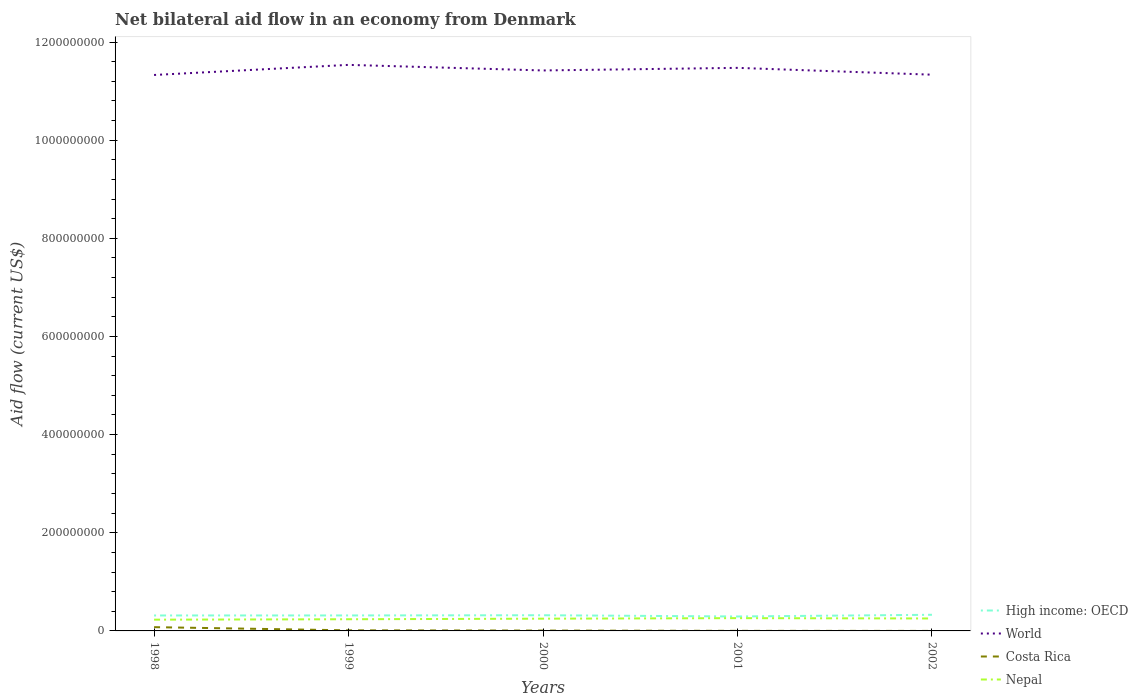Does the line corresponding to Nepal intersect with the line corresponding to High income: OECD?
Your answer should be compact. No. Is the number of lines equal to the number of legend labels?
Keep it short and to the point. Yes. Across all years, what is the maximum net bilateral aid flow in Nepal?
Keep it short and to the point. 2.29e+07. In which year was the net bilateral aid flow in Costa Rica maximum?
Give a very brief answer. 2002. What is the total net bilateral aid flow in Nepal in the graph?
Your response must be concise. -8.80e+05. What is the difference between the highest and the second highest net bilateral aid flow in High income: OECD?
Your answer should be very brief. 3.46e+06. What is the difference between the highest and the lowest net bilateral aid flow in High income: OECD?
Offer a very short reply. 4. Is the net bilateral aid flow in World strictly greater than the net bilateral aid flow in Costa Rica over the years?
Provide a succinct answer. No. How many years are there in the graph?
Ensure brevity in your answer.  5. Are the values on the major ticks of Y-axis written in scientific E-notation?
Make the answer very short. No. Does the graph contain any zero values?
Provide a short and direct response. No. Does the graph contain grids?
Keep it short and to the point. No. How are the legend labels stacked?
Your answer should be very brief. Vertical. What is the title of the graph?
Your response must be concise. Net bilateral aid flow in an economy from Denmark. What is the label or title of the X-axis?
Offer a terse response. Years. What is the Aid flow (current US$) in High income: OECD in 1998?
Make the answer very short. 3.15e+07. What is the Aid flow (current US$) in World in 1998?
Keep it short and to the point. 1.13e+09. What is the Aid flow (current US$) of Costa Rica in 1998?
Give a very brief answer. 7.68e+06. What is the Aid flow (current US$) of Nepal in 1998?
Your answer should be compact. 2.29e+07. What is the Aid flow (current US$) in High income: OECD in 1999?
Make the answer very short. 3.15e+07. What is the Aid flow (current US$) in World in 1999?
Provide a succinct answer. 1.15e+09. What is the Aid flow (current US$) of Costa Rica in 1999?
Your answer should be very brief. 1.19e+06. What is the Aid flow (current US$) in Nepal in 1999?
Your answer should be compact. 2.38e+07. What is the Aid flow (current US$) of High income: OECD in 2000?
Your response must be concise. 3.20e+07. What is the Aid flow (current US$) of World in 2000?
Make the answer very short. 1.14e+09. What is the Aid flow (current US$) of Costa Rica in 2000?
Your answer should be very brief. 7.20e+05. What is the Aid flow (current US$) in Nepal in 2000?
Your answer should be compact. 2.50e+07. What is the Aid flow (current US$) in High income: OECD in 2001?
Offer a very short reply. 2.94e+07. What is the Aid flow (current US$) of World in 2001?
Offer a very short reply. 1.15e+09. What is the Aid flow (current US$) in Costa Rica in 2001?
Give a very brief answer. 1.50e+05. What is the Aid flow (current US$) of Nepal in 2001?
Offer a very short reply. 2.60e+07. What is the Aid flow (current US$) in High income: OECD in 2002?
Provide a succinct answer. 3.29e+07. What is the Aid flow (current US$) in World in 2002?
Your answer should be compact. 1.13e+09. What is the Aid flow (current US$) in Costa Rica in 2002?
Offer a very short reply. 3.00e+04. What is the Aid flow (current US$) of Nepal in 2002?
Make the answer very short. 2.54e+07. Across all years, what is the maximum Aid flow (current US$) of High income: OECD?
Give a very brief answer. 3.29e+07. Across all years, what is the maximum Aid flow (current US$) of World?
Your answer should be compact. 1.15e+09. Across all years, what is the maximum Aid flow (current US$) in Costa Rica?
Keep it short and to the point. 7.68e+06. Across all years, what is the maximum Aid flow (current US$) of Nepal?
Keep it short and to the point. 2.60e+07. Across all years, what is the minimum Aid flow (current US$) in High income: OECD?
Your answer should be very brief. 2.94e+07. Across all years, what is the minimum Aid flow (current US$) in World?
Your response must be concise. 1.13e+09. Across all years, what is the minimum Aid flow (current US$) in Costa Rica?
Your response must be concise. 3.00e+04. Across all years, what is the minimum Aid flow (current US$) in Nepal?
Offer a terse response. 2.29e+07. What is the total Aid flow (current US$) in High income: OECD in the graph?
Make the answer very short. 1.57e+08. What is the total Aid flow (current US$) in World in the graph?
Keep it short and to the point. 5.71e+09. What is the total Aid flow (current US$) of Costa Rica in the graph?
Offer a terse response. 9.77e+06. What is the total Aid flow (current US$) in Nepal in the graph?
Provide a succinct answer. 1.23e+08. What is the difference between the Aid flow (current US$) in World in 1998 and that in 1999?
Give a very brief answer. -2.06e+07. What is the difference between the Aid flow (current US$) in Costa Rica in 1998 and that in 1999?
Provide a short and direct response. 6.49e+06. What is the difference between the Aid flow (current US$) of Nepal in 1998 and that in 1999?
Offer a very short reply. -8.80e+05. What is the difference between the Aid flow (current US$) in High income: OECD in 1998 and that in 2000?
Offer a very short reply. -4.60e+05. What is the difference between the Aid flow (current US$) of World in 1998 and that in 2000?
Offer a terse response. -9.21e+06. What is the difference between the Aid flow (current US$) in Costa Rica in 1998 and that in 2000?
Offer a terse response. 6.96e+06. What is the difference between the Aid flow (current US$) in Nepal in 1998 and that in 2000?
Provide a succinct answer. -2.03e+06. What is the difference between the Aid flow (current US$) of High income: OECD in 1998 and that in 2001?
Provide a short and direct response. 2.07e+06. What is the difference between the Aid flow (current US$) in World in 1998 and that in 2001?
Offer a terse response. -1.45e+07. What is the difference between the Aid flow (current US$) of Costa Rica in 1998 and that in 2001?
Your answer should be very brief. 7.53e+06. What is the difference between the Aid flow (current US$) of Nepal in 1998 and that in 2001?
Keep it short and to the point. -3.13e+06. What is the difference between the Aid flow (current US$) in High income: OECD in 1998 and that in 2002?
Your answer should be very brief. -1.39e+06. What is the difference between the Aid flow (current US$) of World in 1998 and that in 2002?
Make the answer very short. -5.80e+05. What is the difference between the Aid flow (current US$) in Costa Rica in 1998 and that in 2002?
Make the answer very short. 7.65e+06. What is the difference between the Aid flow (current US$) in Nepal in 1998 and that in 2002?
Give a very brief answer. -2.45e+06. What is the difference between the Aid flow (current US$) in High income: OECD in 1999 and that in 2000?
Offer a very short reply. -4.20e+05. What is the difference between the Aid flow (current US$) in World in 1999 and that in 2000?
Provide a short and direct response. 1.14e+07. What is the difference between the Aid flow (current US$) in Costa Rica in 1999 and that in 2000?
Provide a succinct answer. 4.70e+05. What is the difference between the Aid flow (current US$) of Nepal in 1999 and that in 2000?
Make the answer very short. -1.15e+06. What is the difference between the Aid flow (current US$) of High income: OECD in 1999 and that in 2001?
Provide a short and direct response. 2.11e+06. What is the difference between the Aid flow (current US$) in World in 1999 and that in 2001?
Keep it short and to the point. 6.08e+06. What is the difference between the Aid flow (current US$) in Costa Rica in 1999 and that in 2001?
Your answer should be very brief. 1.04e+06. What is the difference between the Aid flow (current US$) of Nepal in 1999 and that in 2001?
Ensure brevity in your answer.  -2.25e+06. What is the difference between the Aid flow (current US$) in High income: OECD in 1999 and that in 2002?
Offer a very short reply. -1.35e+06. What is the difference between the Aid flow (current US$) in World in 1999 and that in 2002?
Offer a terse response. 2.00e+07. What is the difference between the Aid flow (current US$) of Costa Rica in 1999 and that in 2002?
Offer a terse response. 1.16e+06. What is the difference between the Aid flow (current US$) of Nepal in 1999 and that in 2002?
Your answer should be compact. -1.57e+06. What is the difference between the Aid flow (current US$) in High income: OECD in 2000 and that in 2001?
Give a very brief answer. 2.53e+06. What is the difference between the Aid flow (current US$) in World in 2000 and that in 2001?
Provide a succinct answer. -5.28e+06. What is the difference between the Aid flow (current US$) in Costa Rica in 2000 and that in 2001?
Make the answer very short. 5.70e+05. What is the difference between the Aid flow (current US$) in Nepal in 2000 and that in 2001?
Give a very brief answer. -1.10e+06. What is the difference between the Aid flow (current US$) in High income: OECD in 2000 and that in 2002?
Your response must be concise. -9.30e+05. What is the difference between the Aid flow (current US$) of World in 2000 and that in 2002?
Provide a succinct answer. 8.63e+06. What is the difference between the Aid flow (current US$) in Costa Rica in 2000 and that in 2002?
Provide a succinct answer. 6.90e+05. What is the difference between the Aid flow (current US$) of Nepal in 2000 and that in 2002?
Your answer should be compact. -4.20e+05. What is the difference between the Aid flow (current US$) of High income: OECD in 2001 and that in 2002?
Keep it short and to the point. -3.46e+06. What is the difference between the Aid flow (current US$) of World in 2001 and that in 2002?
Provide a succinct answer. 1.39e+07. What is the difference between the Aid flow (current US$) in Costa Rica in 2001 and that in 2002?
Ensure brevity in your answer.  1.20e+05. What is the difference between the Aid flow (current US$) of Nepal in 2001 and that in 2002?
Ensure brevity in your answer.  6.80e+05. What is the difference between the Aid flow (current US$) of High income: OECD in 1998 and the Aid flow (current US$) of World in 1999?
Provide a succinct answer. -1.12e+09. What is the difference between the Aid flow (current US$) in High income: OECD in 1998 and the Aid flow (current US$) in Costa Rica in 1999?
Keep it short and to the point. 3.03e+07. What is the difference between the Aid flow (current US$) in High income: OECD in 1998 and the Aid flow (current US$) in Nepal in 1999?
Your response must be concise. 7.70e+06. What is the difference between the Aid flow (current US$) of World in 1998 and the Aid flow (current US$) of Costa Rica in 1999?
Your answer should be compact. 1.13e+09. What is the difference between the Aid flow (current US$) of World in 1998 and the Aid flow (current US$) of Nepal in 1999?
Ensure brevity in your answer.  1.11e+09. What is the difference between the Aid flow (current US$) in Costa Rica in 1998 and the Aid flow (current US$) in Nepal in 1999?
Ensure brevity in your answer.  -1.61e+07. What is the difference between the Aid flow (current US$) of High income: OECD in 1998 and the Aid flow (current US$) of World in 2000?
Offer a very short reply. -1.11e+09. What is the difference between the Aid flow (current US$) in High income: OECD in 1998 and the Aid flow (current US$) in Costa Rica in 2000?
Make the answer very short. 3.08e+07. What is the difference between the Aid flow (current US$) of High income: OECD in 1998 and the Aid flow (current US$) of Nepal in 2000?
Offer a terse response. 6.55e+06. What is the difference between the Aid flow (current US$) in World in 1998 and the Aid flow (current US$) in Costa Rica in 2000?
Ensure brevity in your answer.  1.13e+09. What is the difference between the Aid flow (current US$) of World in 1998 and the Aid flow (current US$) of Nepal in 2000?
Offer a terse response. 1.11e+09. What is the difference between the Aid flow (current US$) of Costa Rica in 1998 and the Aid flow (current US$) of Nepal in 2000?
Make the answer very short. -1.73e+07. What is the difference between the Aid flow (current US$) of High income: OECD in 1998 and the Aid flow (current US$) of World in 2001?
Give a very brief answer. -1.12e+09. What is the difference between the Aid flow (current US$) in High income: OECD in 1998 and the Aid flow (current US$) in Costa Rica in 2001?
Keep it short and to the point. 3.14e+07. What is the difference between the Aid flow (current US$) in High income: OECD in 1998 and the Aid flow (current US$) in Nepal in 2001?
Your response must be concise. 5.45e+06. What is the difference between the Aid flow (current US$) in World in 1998 and the Aid flow (current US$) in Costa Rica in 2001?
Your answer should be very brief. 1.13e+09. What is the difference between the Aid flow (current US$) of World in 1998 and the Aid flow (current US$) of Nepal in 2001?
Provide a succinct answer. 1.11e+09. What is the difference between the Aid flow (current US$) in Costa Rica in 1998 and the Aid flow (current US$) in Nepal in 2001?
Make the answer very short. -1.84e+07. What is the difference between the Aid flow (current US$) in High income: OECD in 1998 and the Aid flow (current US$) in World in 2002?
Keep it short and to the point. -1.10e+09. What is the difference between the Aid flow (current US$) in High income: OECD in 1998 and the Aid flow (current US$) in Costa Rica in 2002?
Give a very brief answer. 3.15e+07. What is the difference between the Aid flow (current US$) in High income: OECD in 1998 and the Aid flow (current US$) in Nepal in 2002?
Give a very brief answer. 6.13e+06. What is the difference between the Aid flow (current US$) of World in 1998 and the Aid flow (current US$) of Costa Rica in 2002?
Make the answer very short. 1.13e+09. What is the difference between the Aid flow (current US$) in World in 1998 and the Aid flow (current US$) in Nepal in 2002?
Make the answer very short. 1.11e+09. What is the difference between the Aid flow (current US$) of Costa Rica in 1998 and the Aid flow (current US$) of Nepal in 2002?
Make the answer very short. -1.77e+07. What is the difference between the Aid flow (current US$) of High income: OECD in 1999 and the Aid flow (current US$) of World in 2000?
Offer a terse response. -1.11e+09. What is the difference between the Aid flow (current US$) in High income: OECD in 1999 and the Aid flow (current US$) in Costa Rica in 2000?
Your answer should be very brief. 3.08e+07. What is the difference between the Aid flow (current US$) of High income: OECD in 1999 and the Aid flow (current US$) of Nepal in 2000?
Your answer should be compact. 6.59e+06. What is the difference between the Aid flow (current US$) of World in 1999 and the Aid flow (current US$) of Costa Rica in 2000?
Provide a succinct answer. 1.15e+09. What is the difference between the Aid flow (current US$) of World in 1999 and the Aid flow (current US$) of Nepal in 2000?
Provide a succinct answer. 1.13e+09. What is the difference between the Aid flow (current US$) of Costa Rica in 1999 and the Aid flow (current US$) of Nepal in 2000?
Provide a short and direct response. -2.38e+07. What is the difference between the Aid flow (current US$) in High income: OECD in 1999 and the Aid flow (current US$) in World in 2001?
Offer a terse response. -1.12e+09. What is the difference between the Aid flow (current US$) of High income: OECD in 1999 and the Aid flow (current US$) of Costa Rica in 2001?
Offer a terse response. 3.14e+07. What is the difference between the Aid flow (current US$) in High income: OECD in 1999 and the Aid flow (current US$) in Nepal in 2001?
Provide a succinct answer. 5.49e+06. What is the difference between the Aid flow (current US$) of World in 1999 and the Aid flow (current US$) of Costa Rica in 2001?
Offer a very short reply. 1.15e+09. What is the difference between the Aid flow (current US$) in World in 1999 and the Aid flow (current US$) in Nepal in 2001?
Ensure brevity in your answer.  1.13e+09. What is the difference between the Aid flow (current US$) of Costa Rica in 1999 and the Aid flow (current US$) of Nepal in 2001?
Ensure brevity in your answer.  -2.49e+07. What is the difference between the Aid flow (current US$) of High income: OECD in 1999 and the Aid flow (current US$) of World in 2002?
Your answer should be compact. -1.10e+09. What is the difference between the Aid flow (current US$) in High income: OECD in 1999 and the Aid flow (current US$) in Costa Rica in 2002?
Give a very brief answer. 3.15e+07. What is the difference between the Aid flow (current US$) in High income: OECD in 1999 and the Aid flow (current US$) in Nepal in 2002?
Your answer should be compact. 6.17e+06. What is the difference between the Aid flow (current US$) in World in 1999 and the Aid flow (current US$) in Costa Rica in 2002?
Offer a very short reply. 1.15e+09. What is the difference between the Aid flow (current US$) of World in 1999 and the Aid flow (current US$) of Nepal in 2002?
Your answer should be very brief. 1.13e+09. What is the difference between the Aid flow (current US$) in Costa Rica in 1999 and the Aid flow (current US$) in Nepal in 2002?
Offer a terse response. -2.42e+07. What is the difference between the Aid flow (current US$) of High income: OECD in 2000 and the Aid flow (current US$) of World in 2001?
Offer a terse response. -1.12e+09. What is the difference between the Aid flow (current US$) of High income: OECD in 2000 and the Aid flow (current US$) of Costa Rica in 2001?
Offer a very short reply. 3.18e+07. What is the difference between the Aid flow (current US$) in High income: OECD in 2000 and the Aid flow (current US$) in Nepal in 2001?
Provide a short and direct response. 5.91e+06. What is the difference between the Aid flow (current US$) of World in 2000 and the Aid flow (current US$) of Costa Rica in 2001?
Provide a short and direct response. 1.14e+09. What is the difference between the Aid flow (current US$) of World in 2000 and the Aid flow (current US$) of Nepal in 2001?
Offer a terse response. 1.12e+09. What is the difference between the Aid flow (current US$) in Costa Rica in 2000 and the Aid flow (current US$) in Nepal in 2001?
Your response must be concise. -2.53e+07. What is the difference between the Aid flow (current US$) in High income: OECD in 2000 and the Aid flow (current US$) in World in 2002?
Keep it short and to the point. -1.10e+09. What is the difference between the Aid flow (current US$) of High income: OECD in 2000 and the Aid flow (current US$) of Costa Rica in 2002?
Make the answer very short. 3.19e+07. What is the difference between the Aid flow (current US$) in High income: OECD in 2000 and the Aid flow (current US$) in Nepal in 2002?
Make the answer very short. 6.59e+06. What is the difference between the Aid flow (current US$) of World in 2000 and the Aid flow (current US$) of Costa Rica in 2002?
Your response must be concise. 1.14e+09. What is the difference between the Aid flow (current US$) in World in 2000 and the Aid flow (current US$) in Nepal in 2002?
Give a very brief answer. 1.12e+09. What is the difference between the Aid flow (current US$) of Costa Rica in 2000 and the Aid flow (current US$) of Nepal in 2002?
Your answer should be compact. -2.46e+07. What is the difference between the Aid flow (current US$) of High income: OECD in 2001 and the Aid flow (current US$) of World in 2002?
Your response must be concise. -1.10e+09. What is the difference between the Aid flow (current US$) of High income: OECD in 2001 and the Aid flow (current US$) of Costa Rica in 2002?
Offer a very short reply. 2.94e+07. What is the difference between the Aid flow (current US$) of High income: OECD in 2001 and the Aid flow (current US$) of Nepal in 2002?
Ensure brevity in your answer.  4.06e+06. What is the difference between the Aid flow (current US$) in World in 2001 and the Aid flow (current US$) in Costa Rica in 2002?
Your answer should be very brief. 1.15e+09. What is the difference between the Aid flow (current US$) of World in 2001 and the Aid flow (current US$) of Nepal in 2002?
Give a very brief answer. 1.12e+09. What is the difference between the Aid flow (current US$) of Costa Rica in 2001 and the Aid flow (current US$) of Nepal in 2002?
Your response must be concise. -2.52e+07. What is the average Aid flow (current US$) of High income: OECD per year?
Offer a terse response. 3.15e+07. What is the average Aid flow (current US$) of World per year?
Keep it short and to the point. 1.14e+09. What is the average Aid flow (current US$) in Costa Rica per year?
Provide a succinct answer. 1.95e+06. What is the average Aid flow (current US$) in Nepal per year?
Offer a terse response. 2.46e+07. In the year 1998, what is the difference between the Aid flow (current US$) of High income: OECD and Aid flow (current US$) of World?
Your response must be concise. -1.10e+09. In the year 1998, what is the difference between the Aid flow (current US$) in High income: OECD and Aid flow (current US$) in Costa Rica?
Your response must be concise. 2.38e+07. In the year 1998, what is the difference between the Aid flow (current US$) of High income: OECD and Aid flow (current US$) of Nepal?
Offer a very short reply. 8.58e+06. In the year 1998, what is the difference between the Aid flow (current US$) of World and Aid flow (current US$) of Costa Rica?
Your answer should be very brief. 1.13e+09. In the year 1998, what is the difference between the Aid flow (current US$) in World and Aid flow (current US$) in Nepal?
Your answer should be very brief. 1.11e+09. In the year 1998, what is the difference between the Aid flow (current US$) in Costa Rica and Aid flow (current US$) in Nepal?
Provide a short and direct response. -1.52e+07. In the year 1999, what is the difference between the Aid flow (current US$) of High income: OECD and Aid flow (current US$) of World?
Give a very brief answer. -1.12e+09. In the year 1999, what is the difference between the Aid flow (current US$) in High income: OECD and Aid flow (current US$) in Costa Rica?
Make the answer very short. 3.04e+07. In the year 1999, what is the difference between the Aid flow (current US$) of High income: OECD and Aid flow (current US$) of Nepal?
Provide a succinct answer. 7.74e+06. In the year 1999, what is the difference between the Aid flow (current US$) in World and Aid flow (current US$) in Costa Rica?
Offer a terse response. 1.15e+09. In the year 1999, what is the difference between the Aid flow (current US$) of World and Aid flow (current US$) of Nepal?
Provide a succinct answer. 1.13e+09. In the year 1999, what is the difference between the Aid flow (current US$) of Costa Rica and Aid flow (current US$) of Nepal?
Ensure brevity in your answer.  -2.26e+07. In the year 2000, what is the difference between the Aid flow (current US$) in High income: OECD and Aid flow (current US$) in World?
Offer a terse response. -1.11e+09. In the year 2000, what is the difference between the Aid flow (current US$) of High income: OECD and Aid flow (current US$) of Costa Rica?
Provide a succinct answer. 3.12e+07. In the year 2000, what is the difference between the Aid flow (current US$) in High income: OECD and Aid flow (current US$) in Nepal?
Give a very brief answer. 7.01e+06. In the year 2000, what is the difference between the Aid flow (current US$) of World and Aid flow (current US$) of Costa Rica?
Provide a short and direct response. 1.14e+09. In the year 2000, what is the difference between the Aid flow (current US$) of World and Aid flow (current US$) of Nepal?
Your answer should be very brief. 1.12e+09. In the year 2000, what is the difference between the Aid flow (current US$) in Costa Rica and Aid flow (current US$) in Nepal?
Offer a very short reply. -2.42e+07. In the year 2001, what is the difference between the Aid flow (current US$) in High income: OECD and Aid flow (current US$) in World?
Offer a terse response. -1.12e+09. In the year 2001, what is the difference between the Aid flow (current US$) of High income: OECD and Aid flow (current US$) of Costa Rica?
Provide a short and direct response. 2.93e+07. In the year 2001, what is the difference between the Aid flow (current US$) in High income: OECD and Aid flow (current US$) in Nepal?
Your answer should be compact. 3.38e+06. In the year 2001, what is the difference between the Aid flow (current US$) of World and Aid flow (current US$) of Costa Rica?
Your answer should be very brief. 1.15e+09. In the year 2001, what is the difference between the Aid flow (current US$) in World and Aid flow (current US$) in Nepal?
Provide a succinct answer. 1.12e+09. In the year 2001, what is the difference between the Aid flow (current US$) in Costa Rica and Aid flow (current US$) in Nepal?
Offer a terse response. -2.59e+07. In the year 2002, what is the difference between the Aid flow (current US$) of High income: OECD and Aid flow (current US$) of World?
Provide a short and direct response. -1.10e+09. In the year 2002, what is the difference between the Aid flow (current US$) of High income: OECD and Aid flow (current US$) of Costa Rica?
Offer a very short reply. 3.29e+07. In the year 2002, what is the difference between the Aid flow (current US$) of High income: OECD and Aid flow (current US$) of Nepal?
Provide a short and direct response. 7.52e+06. In the year 2002, what is the difference between the Aid flow (current US$) of World and Aid flow (current US$) of Costa Rica?
Make the answer very short. 1.13e+09. In the year 2002, what is the difference between the Aid flow (current US$) in World and Aid flow (current US$) in Nepal?
Provide a succinct answer. 1.11e+09. In the year 2002, what is the difference between the Aid flow (current US$) in Costa Rica and Aid flow (current US$) in Nepal?
Keep it short and to the point. -2.53e+07. What is the ratio of the Aid flow (current US$) of High income: OECD in 1998 to that in 1999?
Keep it short and to the point. 1. What is the ratio of the Aid flow (current US$) of World in 1998 to that in 1999?
Your answer should be compact. 0.98. What is the ratio of the Aid flow (current US$) of Costa Rica in 1998 to that in 1999?
Offer a very short reply. 6.45. What is the ratio of the Aid flow (current US$) of Nepal in 1998 to that in 1999?
Make the answer very short. 0.96. What is the ratio of the Aid flow (current US$) in High income: OECD in 1998 to that in 2000?
Your answer should be compact. 0.99. What is the ratio of the Aid flow (current US$) of Costa Rica in 1998 to that in 2000?
Offer a very short reply. 10.67. What is the ratio of the Aid flow (current US$) in Nepal in 1998 to that in 2000?
Your answer should be compact. 0.92. What is the ratio of the Aid flow (current US$) in High income: OECD in 1998 to that in 2001?
Provide a succinct answer. 1.07. What is the ratio of the Aid flow (current US$) of World in 1998 to that in 2001?
Ensure brevity in your answer.  0.99. What is the ratio of the Aid flow (current US$) in Costa Rica in 1998 to that in 2001?
Offer a very short reply. 51.2. What is the ratio of the Aid flow (current US$) in Nepal in 1998 to that in 2001?
Your answer should be very brief. 0.88. What is the ratio of the Aid flow (current US$) of High income: OECD in 1998 to that in 2002?
Give a very brief answer. 0.96. What is the ratio of the Aid flow (current US$) of Costa Rica in 1998 to that in 2002?
Offer a very short reply. 256. What is the ratio of the Aid flow (current US$) in Nepal in 1998 to that in 2002?
Provide a short and direct response. 0.9. What is the ratio of the Aid flow (current US$) in High income: OECD in 1999 to that in 2000?
Offer a terse response. 0.99. What is the ratio of the Aid flow (current US$) of World in 1999 to that in 2000?
Provide a succinct answer. 1.01. What is the ratio of the Aid flow (current US$) of Costa Rica in 1999 to that in 2000?
Make the answer very short. 1.65. What is the ratio of the Aid flow (current US$) in Nepal in 1999 to that in 2000?
Provide a succinct answer. 0.95. What is the ratio of the Aid flow (current US$) in High income: OECD in 1999 to that in 2001?
Ensure brevity in your answer.  1.07. What is the ratio of the Aid flow (current US$) in Costa Rica in 1999 to that in 2001?
Make the answer very short. 7.93. What is the ratio of the Aid flow (current US$) of Nepal in 1999 to that in 2001?
Make the answer very short. 0.91. What is the ratio of the Aid flow (current US$) of World in 1999 to that in 2002?
Provide a short and direct response. 1.02. What is the ratio of the Aid flow (current US$) of Costa Rica in 1999 to that in 2002?
Provide a succinct answer. 39.67. What is the ratio of the Aid flow (current US$) in Nepal in 1999 to that in 2002?
Make the answer very short. 0.94. What is the ratio of the Aid flow (current US$) of High income: OECD in 2000 to that in 2001?
Offer a very short reply. 1.09. What is the ratio of the Aid flow (current US$) of World in 2000 to that in 2001?
Provide a succinct answer. 1. What is the ratio of the Aid flow (current US$) of Costa Rica in 2000 to that in 2001?
Give a very brief answer. 4.8. What is the ratio of the Aid flow (current US$) in Nepal in 2000 to that in 2001?
Keep it short and to the point. 0.96. What is the ratio of the Aid flow (current US$) in High income: OECD in 2000 to that in 2002?
Your answer should be compact. 0.97. What is the ratio of the Aid flow (current US$) of World in 2000 to that in 2002?
Provide a short and direct response. 1.01. What is the ratio of the Aid flow (current US$) in Nepal in 2000 to that in 2002?
Ensure brevity in your answer.  0.98. What is the ratio of the Aid flow (current US$) in High income: OECD in 2001 to that in 2002?
Ensure brevity in your answer.  0.89. What is the ratio of the Aid flow (current US$) in World in 2001 to that in 2002?
Your response must be concise. 1.01. What is the ratio of the Aid flow (current US$) in Nepal in 2001 to that in 2002?
Offer a terse response. 1.03. What is the difference between the highest and the second highest Aid flow (current US$) in High income: OECD?
Your answer should be compact. 9.30e+05. What is the difference between the highest and the second highest Aid flow (current US$) of World?
Ensure brevity in your answer.  6.08e+06. What is the difference between the highest and the second highest Aid flow (current US$) in Costa Rica?
Ensure brevity in your answer.  6.49e+06. What is the difference between the highest and the second highest Aid flow (current US$) of Nepal?
Offer a very short reply. 6.80e+05. What is the difference between the highest and the lowest Aid flow (current US$) in High income: OECD?
Keep it short and to the point. 3.46e+06. What is the difference between the highest and the lowest Aid flow (current US$) in World?
Give a very brief answer. 2.06e+07. What is the difference between the highest and the lowest Aid flow (current US$) in Costa Rica?
Make the answer very short. 7.65e+06. What is the difference between the highest and the lowest Aid flow (current US$) in Nepal?
Provide a short and direct response. 3.13e+06. 